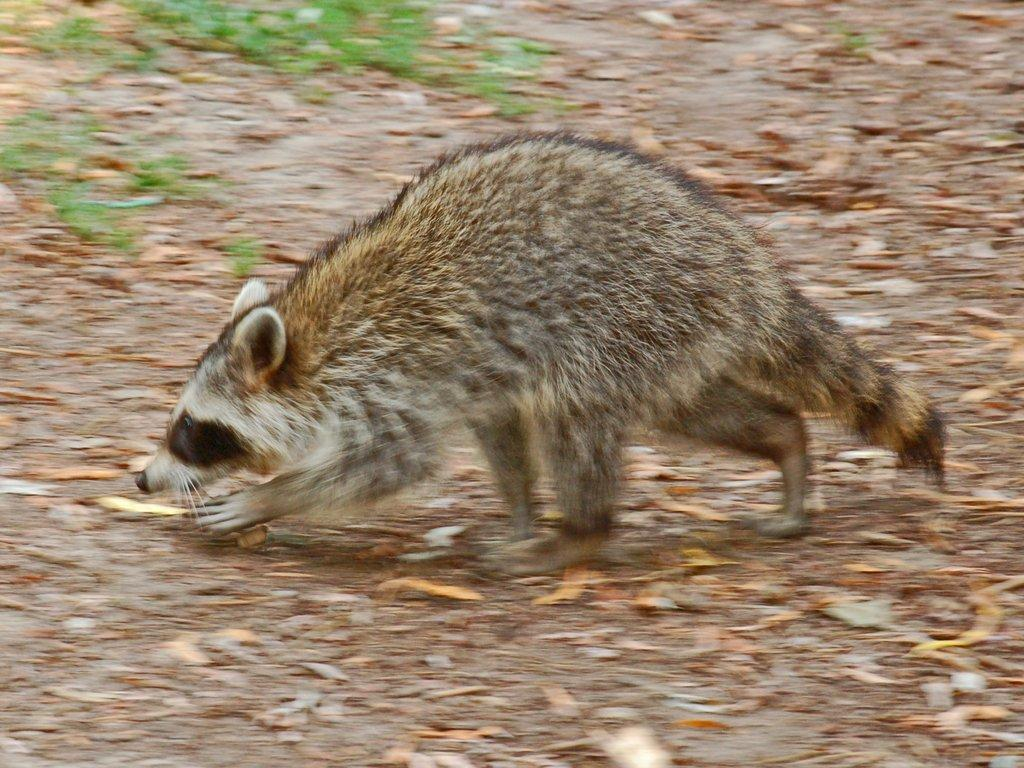What type of creature is present in the image? There is an animal in the image. Where is the animal located? The animal is on the ground. What color is the animal? A: The animal is brown in color. What else can be seen in the image besides the animal? There are dried twigs in the image. Can you tell me how many rows of corn are visible in the image? There is no corn present in the image; it features an animal and dried twigs. What type of ray is swimming in the background of the image? There is no ray present in the image; it features an animal and dried twigs on the ground. 